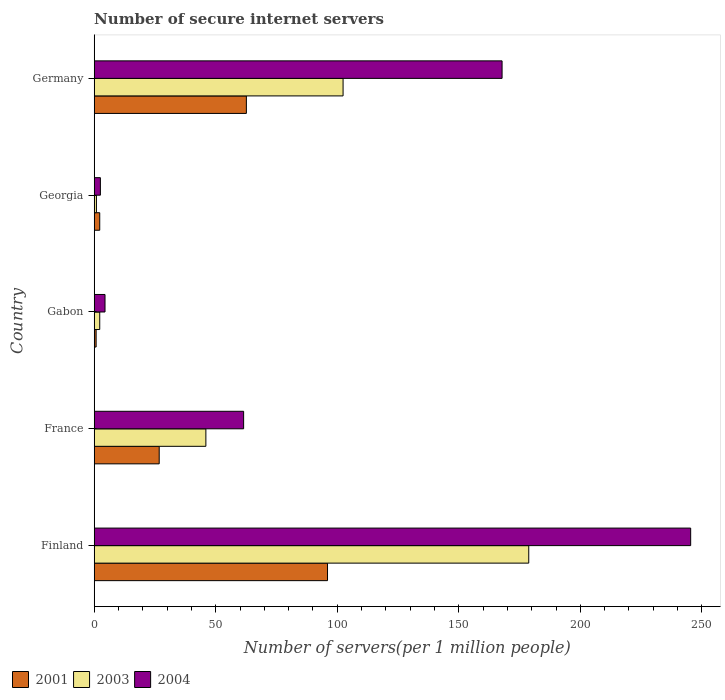How many different coloured bars are there?
Your response must be concise. 3. How many bars are there on the 2nd tick from the top?
Provide a short and direct response. 3. How many bars are there on the 3rd tick from the bottom?
Give a very brief answer. 3. What is the number of secure internet servers in 2001 in Germany?
Give a very brief answer. 62.61. Across all countries, what is the maximum number of secure internet servers in 2003?
Your answer should be very brief. 178.78. Across all countries, what is the minimum number of secure internet servers in 2004?
Your response must be concise. 2.55. In which country was the number of secure internet servers in 2001 maximum?
Your answer should be compact. Finland. In which country was the number of secure internet servers in 2001 minimum?
Provide a succinct answer. Gabon. What is the total number of secure internet servers in 2003 in the graph?
Keep it short and to the point. 330.32. What is the difference between the number of secure internet servers in 2003 in France and that in Gabon?
Keep it short and to the point. 43.67. What is the difference between the number of secure internet servers in 2004 in Gabon and the number of secure internet servers in 2001 in Georgia?
Provide a succinct answer. 2.17. What is the average number of secure internet servers in 2003 per country?
Keep it short and to the point. 66.06. What is the difference between the number of secure internet servers in 2001 and number of secure internet servers in 2004 in Germany?
Give a very brief answer. -105.2. In how many countries, is the number of secure internet servers in 2004 greater than 80 ?
Give a very brief answer. 2. What is the ratio of the number of secure internet servers in 2003 in Finland to that in Gabon?
Ensure brevity in your answer.  78.55. What is the difference between the highest and the second highest number of secure internet servers in 2003?
Offer a very short reply. 76.39. What is the difference between the highest and the lowest number of secure internet servers in 2003?
Offer a very short reply. 177.86. In how many countries, is the number of secure internet servers in 2003 greater than the average number of secure internet servers in 2003 taken over all countries?
Your answer should be compact. 2. Is it the case that in every country, the sum of the number of secure internet servers in 2003 and number of secure internet servers in 2004 is greater than the number of secure internet servers in 2001?
Provide a succinct answer. Yes. How many bars are there?
Ensure brevity in your answer.  15. What is the difference between two consecutive major ticks on the X-axis?
Your response must be concise. 50. Are the values on the major ticks of X-axis written in scientific E-notation?
Provide a short and direct response. No. Does the graph contain grids?
Offer a very short reply. No. Where does the legend appear in the graph?
Keep it short and to the point. Bottom left. How are the legend labels stacked?
Provide a short and direct response. Horizontal. What is the title of the graph?
Ensure brevity in your answer.  Number of secure internet servers. Does "1973" appear as one of the legend labels in the graph?
Provide a short and direct response. No. What is the label or title of the X-axis?
Give a very brief answer. Number of servers(per 1 million people). What is the Number of servers(per 1 million people) of 2001 in Finland?
Your response must be concise. 95.99. What is the Number of servers(per 1 million people) of 2003 in Finland?
Provide a short and direct response. 178.78. What is the Number of servers(per 1 million people) in 2004 in Finland?
Offer a terse response. 245.4. What is the Number of servers(per 1 million people) in 2001 in France?
Make the answer very short. 26.74. What is the Number of servers(per 1 million people) of 2003 in France?
Ensure brevity in your answer.  45.95. What is the Number of servers(per 1 million people) in 2004 in France?
Your answer should be compact. 61.48. What is the Number of servers(per 1 million people) in 2001 in Gabon?
Provide a short and direct response. 0.79. What is the Number of servers(per 1 million people) of 2003 in Gabon?
Ensure brevity in your answer.  2.28. What is the Number of servers(per 1 million people) of 2004 in Gabon?
Ensure brevity in your answer.  4.45. What is the Number of servers(per 1 million people) of 2001 in Georgia?
Your response must be concise. 2.28. What is the Number of servers(per 1 million people) in 2003 in Georgia?
Provide a succinct answer. 0.92. What is the Number of servers(per 1 million people) in 2004 in Georgia?
Provide a short and direct response. 2.55. What is the Number of servers(per 1 million people) in 2001 in Germany?
Provide a succinct answer. 62.61. What is the Number of servers(per 1 million people) of 2003 in Germany?
Offer a very short reply. 102.39. What is the Number of servers(per 1 million people) in 2004 in Germany?
Offer a terse response. 167.81. Across all countries, what is the maximum Number of servers(per 1 million people) in 2001?
Make the answer very short. 95.99. Across all countries, what is the maximum Number of servers(per 1 million people) of 2003?
Ensure brevity in your answer.  178.78. Across all countries, what is the maximum Number of servers(per 1 million people) in 2004?
Provide a succinct answer. 245.4. Across all countries, what is the minimum Number of servers(per 1 million people) in 2001?
Provide a succinct answer. 0.79. Across all countries, what is the minimum Number of servers(per 1 million people) of 2003?
Keep it short and to the point. 0.92. Across all countries, what is the minimum Number of servers(per 1 million people) in 2004?
Ensure brevity in your answer.  2.55. What is the total Number of servers(per 1 million people) of 2001 in the graph?
Provide a succinct answer. 188.42. What is the total Number of servers(per 1 million people) in 2003 in the graph?
Offer a very short reply. 330.32. What is the total Number of servers(per 1 million people) in 2004 in the graph?
Provide a short and direct response. 481.69. What is the difference between the Number of servers(per 1 million people) in 2001 in Finland and that in France?
Provide a short and direct response. 69.25. What is the difference between the Number of servers(per 1 million people) of 2003 in Finland and that in France?
Provide a succinct answer. 132.84. What is the difference between the Number of servers(per 1 million people) in 2004 in Finland and that in France?
Keep it short and to the point. 183.92. What is the difference between the Number of servers(per 1 million people) in 2001 in Finland and that in Gabon?
Give a very brief answer. 95.2. What is the difference between the Number of servers(per 1 million people) in 2003 in Finland and that in Gabon?
Your response must be concise. 176.51. What is the difference between the Number of servers(per 1 million people) in 2004 in Finland and that in Gabon?
Make the answer very short. 240.95. What is the difference between the Number of servers(per 1 million people) of 2001 in Finland and that in Georgia?
Your answer should be very brief. 93.71. What is the difference between the Number of servers(per 1 million people) in 2003 in Finland and that in Georgia?
Your answer should be very brief. 177.86. What is the difference between the Number of servers(per 1 million people) of 2004 in Finland and that in Georgia?
Offer a very short reply. 242.85. What is the difference between the Number of servers(per 1 million people) in 2001 in Finland and that in Germany?
Your answer should be compact. 33.38. What is the difference between the Number of servers(per 1 million people) in 2003 in Finland and that in Germany?
Give a very brief answer. 76.39. What is the difference between the Number of servers(per 1 million people) in 2004 in Finland and that in Germany?
Provide a short and direct response. 77.59. What is the difference between the Number of servers(per 1 million people) in 2001 in France and that in Gabon?
Offer a very short reply. 25.95. What is the difference between the Number of servers(per 1 million people) in 2003 in France and that in Gabon?
Provide a succinct answer. 43.67. What is the difference between the Number of servers(per 1 million people) of 2004 in France and that in Gabon?
Offer a terse response. 57.03. What is the difference between the Number of servers(per 1 million people) of 2001 in France and that in Georgia?
Your answer should be compact. 24.47. What is the difference between the Number of servers(per 1 million people) of 2003 in France and that in Georgia?
Provide a short and direct response. 45.02. What is the difference between the Number of servers(per 1 million people) of 2004 in France and that in Georgia?
Give a very brief answer. 58.93. What is the difference between the Number of servers(per 1 million people) in 2001 in France and that in Germany?
Ensure brevity in your answer.  -35.87. What is the difference between the Number of servers(per 1 million people) in 2003 in France and that in Germany?
Provide a succinct answer. -56.45. What is the difference between the Number of servers(per 1 million people) of 2004 in France and that in Germany?
Offer a terse response. -106.33. What is the difference between the Number of servers(per 1 million people) of 2001 in Gabon and that in Georgia?
Ensure brevity in your answer.  -1.49. What is the difference between the Number of servers(per 1 million people) of 2003 in Gabon and that in Georgia?
Your answer should be compact. 1.35. What is the difference between the Number of servers(per 1 million people) in 2004 in Gabon and that in Georgia?
Ensure brevity in your answer.  1.91. What is the difference between the Number of servers(per 1 million people) of 2001 in Gabon and that in Germany?
Keep it short and to the point. -61.82. What is the difference between the Number of servers(per 1 million people) in 2003 in Gabon and that in Germany?
Offer a terse response. -100.12. What is the difference between the Number of servers(per 1 million people) in 2004 in Gabon and that in Germany?
Your answer should be very brief. -163.36. What is the difference between the Number of servers(per 1 million people) of 2001 in Georgia and that in Germany?
Your answer should be very brief. -60.33. What is the difference between the Number of servers(per 1 million people) in 2003 in Georgia and that in Germany?
Your response must be concise. -101.47. What is the difference between the Number of servers(per 1 million people) in 2004 in Georgia and that in Germany?
Provide a succinct answer. -165.26. What is the difference between the Number of servers(per 1 million people) of 2001 in Finland and the Number of servers(per 1 million people) of 2003 in France?
Provide a succinct answer. 50.04. What is the difference between the Number of servers(per 1 million people) in 2001 in Finland and the Number of servers(per 1 million people) in 2004 in France?
Offer a very short reply. 34.51. What is the difference between the Number of servers(per 1 million people) of 2003 in Finland and the Number of servers(per 1 million people) of 2004 in France?
Your answer should be compact. 117.3. What is the difference between the Number of servers(per 1 million people) in 2001 in Finland and the Number of servers(per 1 million people) in 2003 in Gabon?
Your answer should be compact. 93.71. What is the difference between the Number of servers(per 1 million people) of 2001 in Finland and the Number of servers(per 1 million people) of 2004 in Gabon?
Give a very brief answer. 91.54. What is the difference between the Number of servers(per 1 million people) in 2003 in Finland and the Number of servers(per 1 million people) in 2004 in Gabon?
Your answer should be very brief. 174.33. What is the difference between the Number of servers(per 1 million people) of 2001 in Finland and the Number of servers(per 1 million people) of 2003 in Georgia?
Ensure brevity in your answer.  95.07. What is the difference between the Number of servers(per 1 million people) of 2001 in Finland and the Number of servers(per 1 million people) of 2004 in Georgia?
Ensure brevity in your answer.  93.44. What is the difference between the Number of servers(per 1 million people) in 2003 in Finland and the Number of servers(per 1 million people) in 2004 in Georgia?
Offer a very short reply. 176.24. What is the difference between the Number of servers(per 1 million people) of 2001 in Finland and the Number of servers(per 1 million people) of 2003 in Germany?
Offer a very short reply. -6.4. What is the difference between the Number of servers(per 1 million people) in 2001 in Finland and the Number of servers(per 1 million people) in 2004 in Germany?
Your response must be concise. -71.82. What is the difference between the Number of servers(per 1 million people) in 2003 in Finland and the Number of servers(per 1 million people) in 2004 in Germany?
Keep it short and to the point. 10.97. What is the difference between the Number of servers(per 1 million people) in 2001 in France and the Number of servers(per 1 million people) in 2003 in Gabon?
Your response must be concise. 24.47. What is the difference between the Number of servers(per 1 million people) in 2001 in France and the Number of servers(per 1 million people) in 2004 in Gabon?
Provide a succinct answer. 22.29. What is the difference between the Number of servers(per 1 million people) of 2003 in France and the Number of servers(per 1 million people) of 2004 in Gabon?
Your answer should be compact. 41.49. What is the difference between the Number of servers(per 1 million people) of 2001 in France and the Number of servers(per 1 million people) of 2003 in Georgia?
Your answer should be very brief. 25.82. What is the difference between the Number of servers(per 1 million people) in 2001 in France and the Number of servers(per 1 million people) in 2004 in Georgia?
Your answer should be compact. 24.2. What is the difference between the Number of servers(per 1 million people) in 2003 in France and the Number of servers(per 1 million people) in 2004 in Georgia?
Provide a succinct answer. 43.4. What is the difference between the Number of servers(per 1 million people) of 2001 in France and the Number of servers(per 1 million people) of 2003 in Germany?
Keep it short and to the point. -75.65. What is the difference between the Number of servers(per 1 million people) of 2001 in France and the Number of servers(per 1 million people) of 2004 in Germany?
Ensure brevity in your answer.  -141.06. What is the difference between the Number of servers(per 1 million people) in 2003 in France and the Number of servers(per 1 million people) in 2004 in Germany?
Make the answer very short. -121.86. What is the difference between the Number of servers(per 1 million people) of 2001 in Gabon and the Number of servers(per 1 million people) of 2003 in Georgia?
Keep it short and to the point. -0.13. What is the difference between the Number of servers(per 1 million people) of 2001 in Gabon and the Number of servers(per 1 million people) of 2004 in Georgia?
Give a very brief answer. -1.75. What is the difference between the Number of servers(per 1 million people) of 2003 in Gabon and the Number of servers(per 1 million people) of 2004 in Georgia?
Your answer should be very brief. -0.27. What is the difference between the Number of servers(per 1 million people) of 2001 in Gabon and the Number of servers(per 1 million people) of 2003 in Germany?
Provide a short and direct response. -101.6. What is the difference between the Number of servers(per 1 million people) of 2001 in Gabon and the Number of servers(per 1 million people) of 2004 in Germany?
Your answer should be very brief. -167.02. What is the difference between the Number of servers(per 1 million people) of 2003 in Gabon and the Number of servers(per 1 million people) of 2004 in Germany?
Provide a succinct answer. -165.53. What is the difference between the Number of servers(per 1 million people) in 2001 in Georgia and the Number of servers(per 1 million people) in 2003 in Germany?
Your answer should be compact. -100.11. What is the difference between the Number of servers(per 1 million people) in 2001 in Georgia and the Number of servers(per 1 million people) in 2004 in Germany?
Offer a very short reply. -165.53. What is the difference between the Number of servers(per 1 million people) of 2003 in Georgia and the Number of servers(per 1 million people) of 2004 in Germany?
Your answer should be compact. -166.89. What is the average Number of servers(per 1 million people) of 2001 per country?
Provide a succinct answer. 37.68. What is the average Number of servers(per 1 million people) of 2003 per country?
Keep it short and to the point. 66.06. What is the average Number of servers(per 1 million people) of 2004 per country?
Make the answer very short. 96.34. What is the difference between the Number of servers(per 1 million people) of 2001 and Number of servers(per 1 million people) of 2003 in Finland?
Offer a terse response. -82.79. What is the difference between the Number of servers(per 1 million people) in 2001 and Number of servers(per 1 million people) in 2004 in Finland?
Offer a terse response. -149.41. What is the difference between the Number of servers(per 1 million people) of 2003 and Number of servers(per 1 million people) of 2004 in Finland?
Ensure brevity in your answer.  -66.62. What is the difference between the Number of servers(per 1 million people) in 2001 and Number of servers(per 1 million people) in 2003 in France?
Offer a very short reply. -19.2. What is the difference between the Number of servers(per 1 million people) in 2001 and Number of servers(per 1 million people) in 2004 in France?
Give a very brief answer. -34.73. What is the difference between the Number of servers(per 1 million people) of 2003 and Number of servers(per 1 million people) of 2004 in France?
Your response must be concise. -15.53. What is the difference between the Number of servers(per 1 million people) of 2001 and Number of servers(per 1 million people) of 2003 in Gabon?
Your answer should be very brief. -1.48. What is the difference between the Number of servers(per 1 million people) in 2001 and Number of servers(per 1 million people) in 2004 in Gabon?
Ensure brevity in your answer.  -3.66. What is the difference between the Number of servers(per 1 million people) in 2003 and Number of servers(per 1 million people) in 2004 in Gabon?
Offer a very short reply. -2.18. What is the difference between the Number of servers(per 1 million people) of 2001 and Number of servers(per 1 million people) of 2003 in Georgia?
Keep it short and to the point. 1.36. What is the difference between the Number of servers(per 1 million people) in 2001 and Number of servers(per 1 million people) in 2004 in Georgia?
Give a very brief answer. -0.27. What is the difference between the Number of servers(per 1 million people) in 2003 and Number of servers(per 1 million people) in 2004 in Georgia?
Your response must be concise. -1.62. What is the difference between the Number of servers(per 1 million people) of 2001 and Number of servers(per 1 million people) of 2003 in Germany?
Your answer should be compact. -39.78. What is the difference between the Number of servers(per 1 million people) of 2001 and Number of servers(per 1 million people) of 2004 in Germany?
Offer a terse response. -105.2. What is the difference between the Number of servers(per 1 million people) of 2003 and Number of servers(per 1 million people) of 2004 in Germany?
Your answer should be very brief. -65.42. What is the ratio of the Number of servers(per 1 million people) in 2001 in Finland to that in France?
Offer a very short reply. 3.59. What is the ratio of the Number of servers(per 1 million people) of 2003 in Finland to that in France?
Make the answer very short. 3.89. What is the ratio of the Number of servers(per 1 million people) of 2004 in Finland to that in France?
Ensure brevity in your answer.  3.99. What is the ratio of the Number of servers(per 1 million people) of 2001 in Finland to that in Gabon?
Offer a very short reply. 120.99. What is the ratio of the Number of servers(per 1 million people) in 2003 in Finland to that in Gabon?
Your answer should be compact. 78.55. What is the ratio of the Number of servers(per 1 million people) in 2004 in Finland to that in Gabon?
Make the answer very short. 55.11. What is the ratio of the Number of servers(per 1 million people) of 2001 in Finland to that in Georgia?
Your answer should be compact. 42.11. What is the ratio of the Number of servers(per 1 million people) of 2003 in Finland to that in Georgia?
Make the answer very short. 193.48. What is the ratio of the Number of servers(per 1 million people) of 2004 in Finland to that in Georgia?
Your response must be concise. 96.34. What is the ratio of the Number of servers(per 1 million people) in 2001 in Finland to that in Germany?
Ensure brevity in your answer.  1.53. What is the ratio of the Number of servers(per 1 million people) of 2003 in Finland to that in Germany?
Your answer should be compact. 1.75. What is the ratio of the Number of servers(per 1 million people) of 2004 in Finland to that in Germany?
Give a very brief answer. 1.46. What is the ratio of the Number of servers(per 1 million people) in 2001 in France to that in Gabon?
Ensure brevity in your answer.  33.71. What is the ratio of the Number of servers(per 1 million people) of 2003 in France to that in Gabon?
Offer a terse response. 20.19. What is the ratio of the Number of servers(per 1 million people) in 2004 in France to that in Gabon?
Your answer should be compact. 13.81. What is the ratio of the Number of servers(per 1 million people) of 2001 in France to that in Georgia?
Provide a short and direct response. 11.73. What is the ratio of the Number of servers(per 1 million people) of 2003 in France to that in Georgia?
Offer a very short reply. 49.73. What is the ratio of the Number of servers(per 1 million people) in 2004 in France to that in Georgia?
Ensure brevity in your answer.  24.13. What is the ratio of the Number of servers(per 1 million people) in 2001 in France to that in Germany?
Offer a very short reply. 0.43. What is the ratio of the Number of servers(per 1 million people) of 2003 in France to that in Germany?
Keep it short and to the point. 0.45. What is the ratio of the Number of servers(per 1 million people) of 2004 in France to that in Germany?
Make the answer very short. 0.37. What is the ratio of the Number of servers(per 1 million people) of 2001 in Gabon to that in Georgia?
Ensure brevity in your answer.  0.35. What is the ratio of the Number of servers(per 1 million people) in 2003 in Gabon to that in Georgia?
Your answer should be compact. 2.46. What is the ratio of the Number of servers(per 1 million people) of 2004 in Gabon to that in Georgia?
Offer a terse response. 1.75. What is the ratio of the Number of servers(per 1 million people) of 2001 in Gabon to that in Germany?
Your answer should be very brief. 0.01. What is the ratio of the Number of servers(per 1 million people) in 2003 in Gabon to that in Germany?
Ensure brevity in your answer.  0.02. What is the ratio of the Number of servers(per 1 million people) of 2004 in Gabon to that in Germany?
Make the answer very short. 0.03. What is the ratio of the Number of servers(per 1 million people) in 2001 in Georgia to that in Germany?
Offer a very short reply. 0.04. What is the ratio of the Number of servers(per 1 million people) of 2003 in Georgia to that in Germany?
Your response must be concise. 0.01. What is the ratio of the Number of servers(per 1 million people) in 2004 in Georgia to that in Germany?
Provide a short and direct response. 0.02. What is the difference between the highest and the second highest Number of servers(per 1 million people) of 2001?
Offer a very short reply. 33.38. What is the difference between the highest and the second highest Number of servers(per 1 million people) in 2003?
Keep it short and to the point. 76.39. What is the difference between the highest and the second highest Number of servers(per 1 million people) of 2004?
Keep it short and to the point. 77.59. What is the difference between the highest and the lowest Number of servers(per 1 million people) of 2001?
Give a very brief answer. 95.2. What is the difference between the highest and the lowest Number of servers(per 1 million people) of 2003?
Provide a short and direct response. 177.86. What is the difference between the highest and the lowest Number of servers(per 1 million people) in 2004?
Provide a short and direct response. 242.85. 